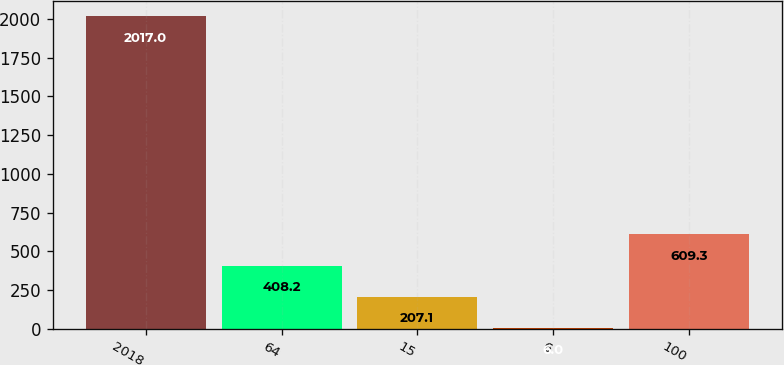<chart> <loc_0><loc_0><loc_500><loc_500><bar_chart><fcel>2018<fcel>64<fcel>15<fcel>6<fcel>100<nl><fcel>2017<fcel>408.2<fcel>207.1<fcel>6<fcel>609.3<nl></chart> 